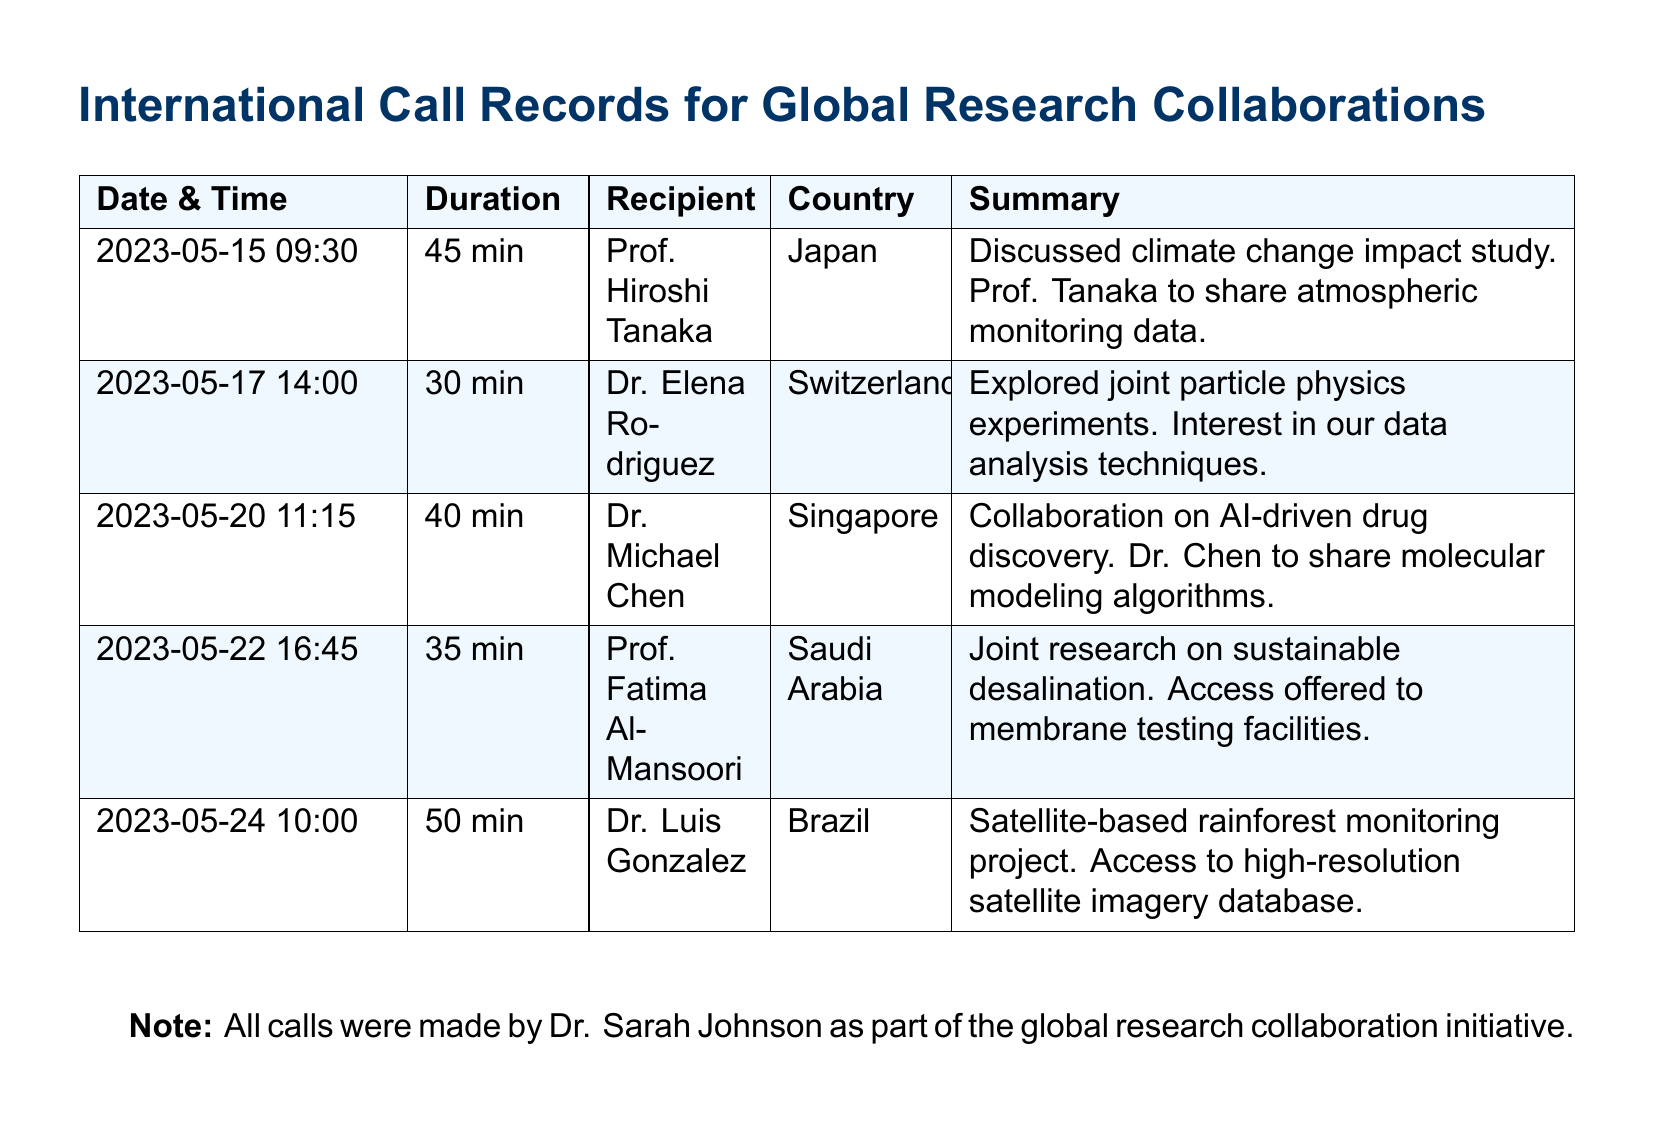what is the date of the call with Prof. Hiroshi Tanaka? The date of the call with Prof. Hiroshi Tanaka is listed in the document as 2023-05-15.
Answer: 2023-05-15 how long was the call with Dr. Elena Rodriguez? The duration of the call with Dr. Elena Rodriguez is specified as 30 minutes in the records.
Answer: 30 min which country was Dr. Michael Chen from? The document indicates that Dr. Michael Chen was from Singapore.
Answer: Singapore what research topic was discussed with Prof. Fatima Al-Mansoori? The topic discussed with Prof. Fatima Al-Mansoori involved sustainable desalination, according to the summary in the records.
Answer: sustainable desalination how many minutes did the call with Dr. Luis Gonzalez last? The duration of the call with Dr. Luis Gonzalez is recorded as 50 minutes.
Answer: 50 min which type of collaboration was mentioned in the call with Dr. Michael Chen? The type of collaboration with Dr. Michael Chen involved AI-driven drug discovery.
Answer: AI-driven drug discovery who made all the calls in the document? The document states that all calls were made by Dr. Sarah Johnson.
Answer: Dr. Sarah Johnson what was offered by Prof. Fatima Al-Mansoori during the call? The summary mentions that access to membrane testing facilities was offered by Prof. Fatima Al-Mansoori.
Answer: access to membrane testing facilities what kind of data was Prof. Hiroshi Tanaka supposed to share? The document mentions that Prof. Tanaka was to share atmospheric monitoring data.
Answer: atmospheric monitoring data 